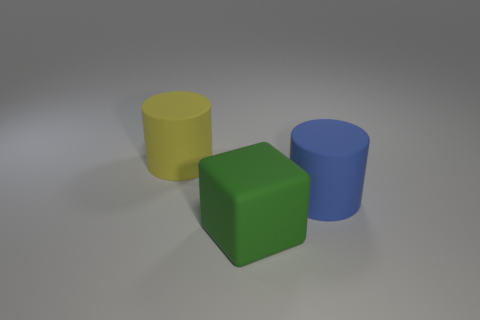Is the number of green objects behind the big cube the same as the number of large things that are in front of the big yellow rubber cylinder?
Provide a short and direct response. No. There is a rubber block; are there any matte objects behind it?
Make the answer very short. Yes. What is the color of the big matte cylinder that is right of the yellow rubber object?
Your answer should be very brief. Blue. There is a cylinder in front of the rubber cylinder that is left of the large green rubber cube; what is its material?
Give a very brief answer. Rubber. Is the number of blue things right of the blue cylinder less than the number of matte cylinders that are to the left of the green matte block?
Your response must be concise. Yes. How many green objects are either small matte cylinders or large blocks?
Keep it short and to the point. 1. Are there an equal number of matte cubes that are right of the large matte block and large blue rubber balls?
Provide a short and direct response. Yes. What number of objects are green things or things behind the big green object?
Your answer should be compact. 3. Is there a large green block made of the same material as the large yellow object?
Your answer should be very brief. Yes. What is the color of the other rubber object that is the same shape as the blue rubber thing?
Offer a terse response. Yellow. 